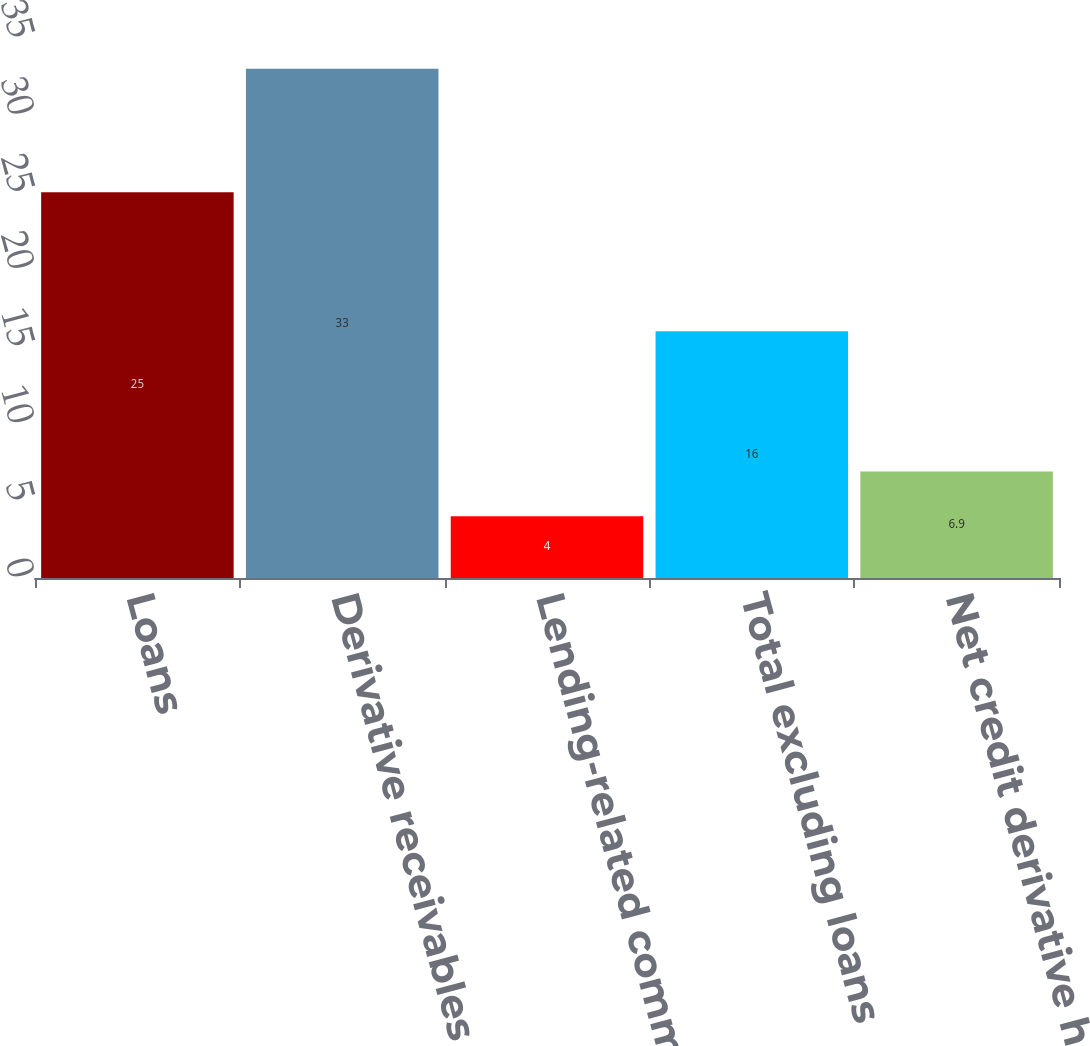Convert chart to OTSL. <chart><loc_0><loc_0><loc_500><loc_500><bar_chart><fcel>Loans<fcel>Derivative receivables<fcel>Lending-related commitments<fcel>Total excluding loans<fcel>Net credit derivative hedges<nl><fcel>25<fcel>33<fcel>4<fcel>16<fcel>6.9<nl></chart> 